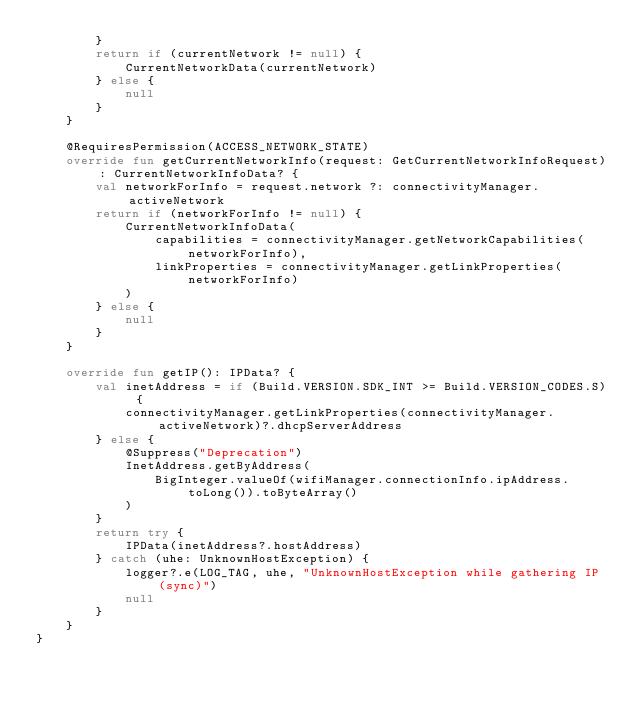Convert code to text. <code><loc_0><loc_0><loc_500><loc_500><_Kotlin_>        }
        return if (currentNetwork != null) {
            CurrentNetworkData(currentNetwork)
        } else {
            null
        }
    }

    @RequiresPermission(ACCESS_NETWORK_STATE)
    override fun getCurrentNetworkInfo(request: GetCurrentNetworkInfoRequest): CurrentNetworkInfoData? {
        val networkForInfo = request.network ?: connectivityManager.activeNetwork
        return if (networkForInfo != null) {
            CurrentNetworkInfoData(
                capabilities = connectivityManager.getNetworkCapabilities(networkForInfo),
                linkProperties = connectivityManager.getLinkProperties(networkForInfo)
            )
        } else {
            null
        }
    }

    override fun getIP(): IPData? {
        val inetAddress = if (Build.VERSION.SDK_INT >= Build.VERSION_CODES.S) {
            connectivityManager.getLinkProperties(connectivityManager.activeNetwork)?.dhcpServerAddress
        } else {
            @Suppress("Deprecation")
            InetAddress.getByAddress(
                BigInteger.valueOf(wifiManager.connectionInfo.ipAddress.toLong()).toByteArray()
            )
        }
        return try {
            IPData(inetAddress?.hostAddress)
        } catch (uhe: UnknownHostException) {
            logger?.e(LOG_TAG, uhe, "UnknownHostException while gathering IP (sync)")
            null
        }
    }
}
</code> 